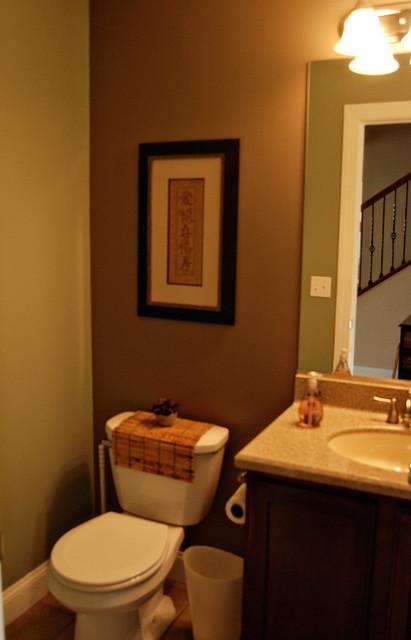What is pictured in the mirror?
Concise answer only. Stairs. What color is the toilet on the left?
Be succinct. White. What is on the back of the toilet?
Write a very short answer. Towel. Is this bathroom masculine?
Quick response, please. No. How many things can a person plug in?
Answer briefly. 0. Where is the toilet paper?
Concise answer only. On holder. What objects are reflected in the mirror?
Keep it brief. Staircase. 